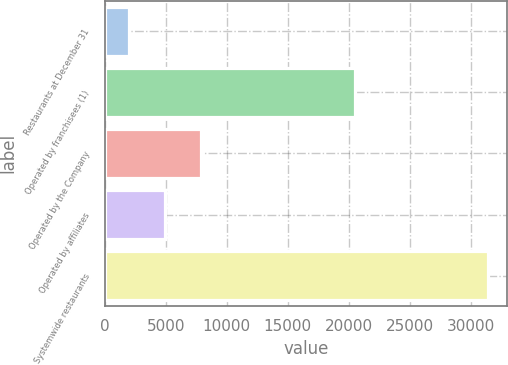<chart> <loc_0><loc_0><loc_500><loc_500><bar_chart><fcel>Restaurants at December 31<fcel>Operated by franchisees (1)<fcel>Operated by the Company<fcel>Operated by affiliates<fcel>Systemwide restaurants<nl><fcel>2007<fcel>20505<fcel>7881<fcel>4944<fcel>31377<nl></chart> 